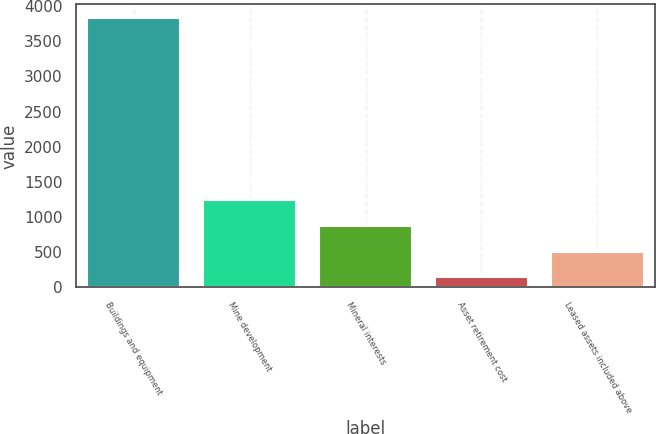<chart> <loc_0><loc_0><loc_500><loc_500><bar_chart><fcel>Buildings and equipment<fcel>Mine development<fcel>Mineral interests<fcel>Asset retirement cost<fcel>Leased assets included above<nl><fcel>3832<fcel>1248.3<fcel>879.2<fcel>141<fcel>510.1<nl></chart> 